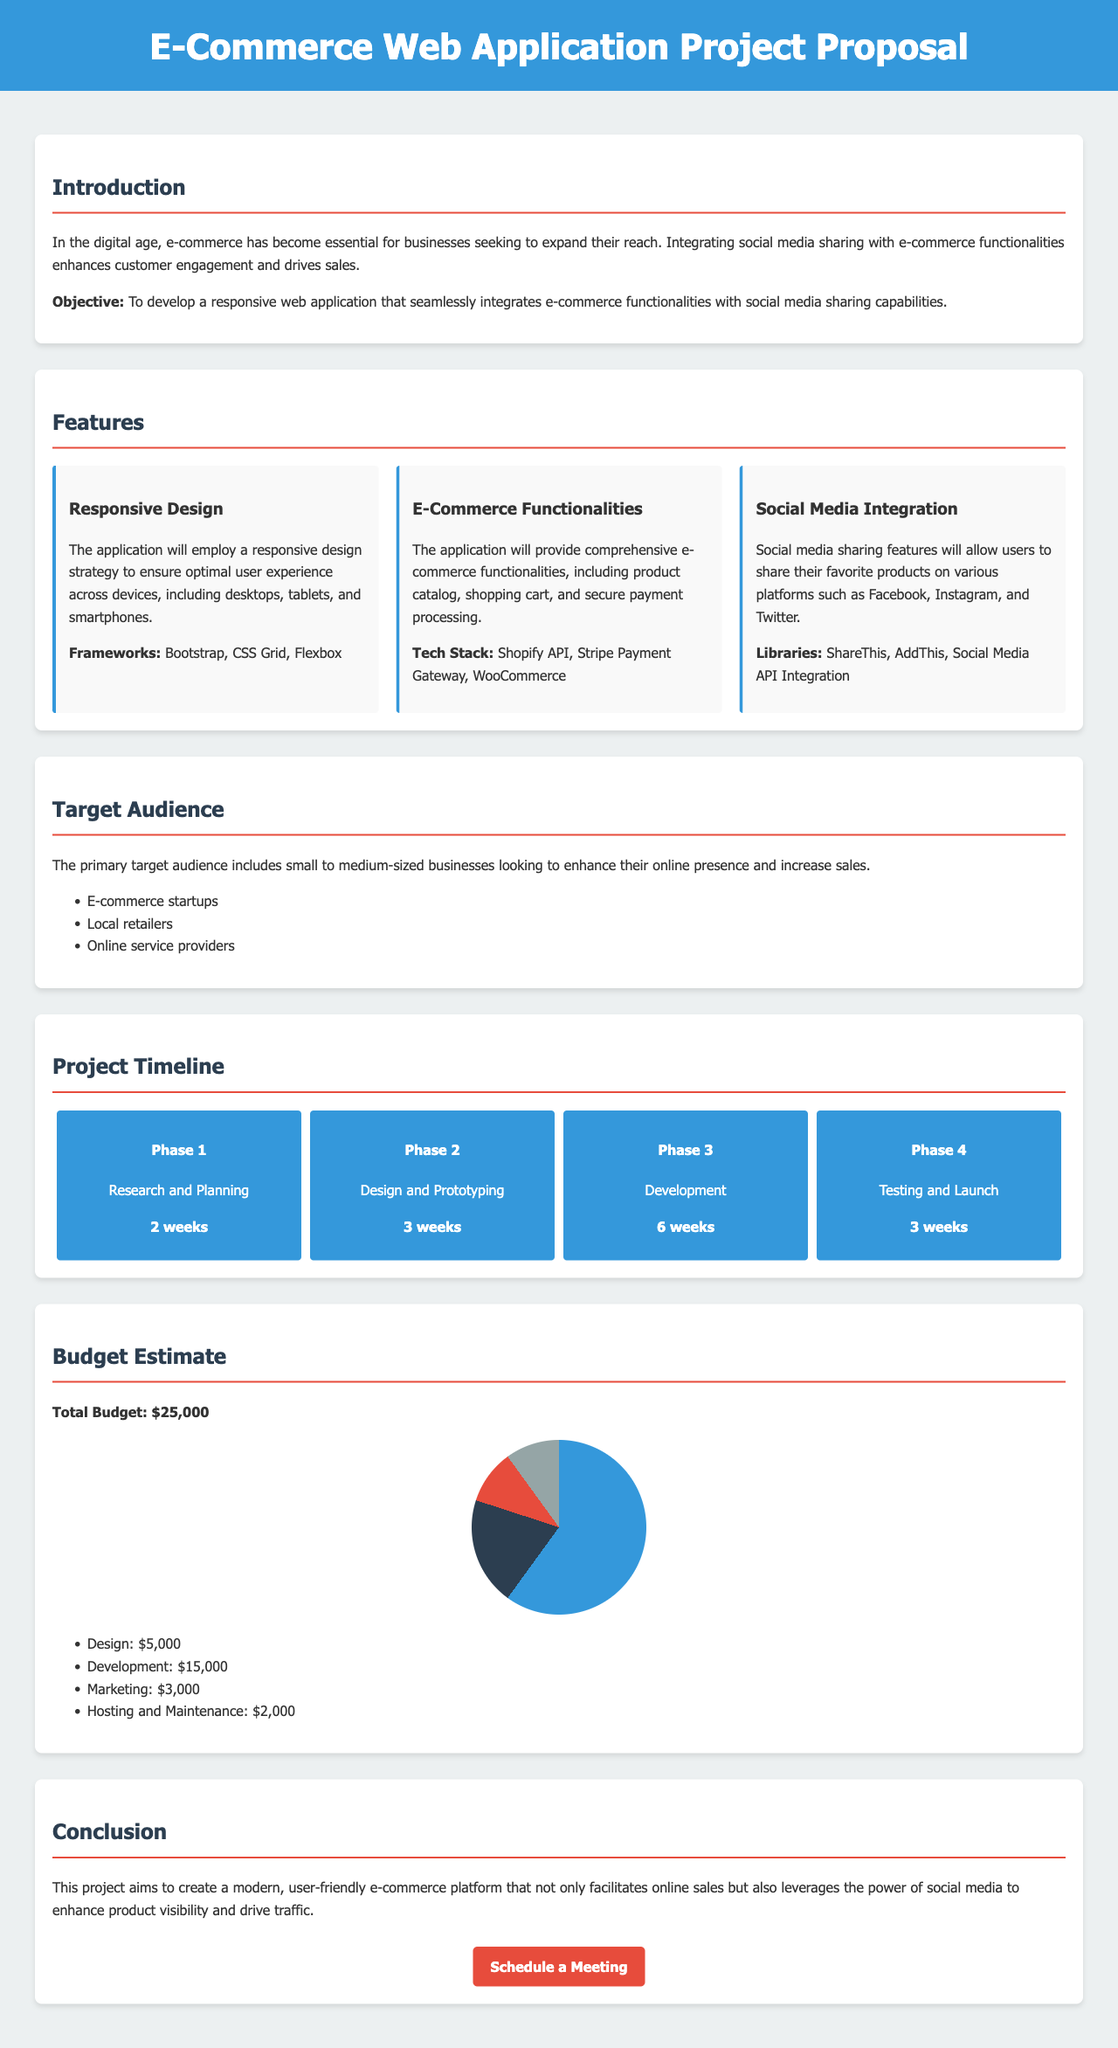What is the primary objective of the project? The objective is stated in the introduction section of the document, which is to develop a responsive web application that integrates e-commerce functionalities with social media sharing capabilities.
Answer: To develop a responsive web application that seamlessly integrates e-commerce functionalities with social media sharing capabilities What is the total budget for the project? The total budget is specified in the budget estimate section of the document.
Answer: $25,000 How many phases are in the project timeline? Counting the phases listed in the project timeline section, there are four phases.
Answer: 4 Which library is used for social media integration? The document mentions various libraries for social media integration in the features section.
Answer: ShareThis What is the duration of the Development phase? The duration for the Development phase is found in the timeline section, which specifies how long this phase is scheduled to take.
Answer: 6 weeks What features will be included in the e-commerce functionalities? The document outlines that the application will include a product catalog, shopping cart, and secure payment processing.
Answer: Product catalog, shopping cart, and secure payment processing Who is the primary target audience for this project? The target audience is described in the target audience section of the document.
Answer: Small to medium-sized businesses 